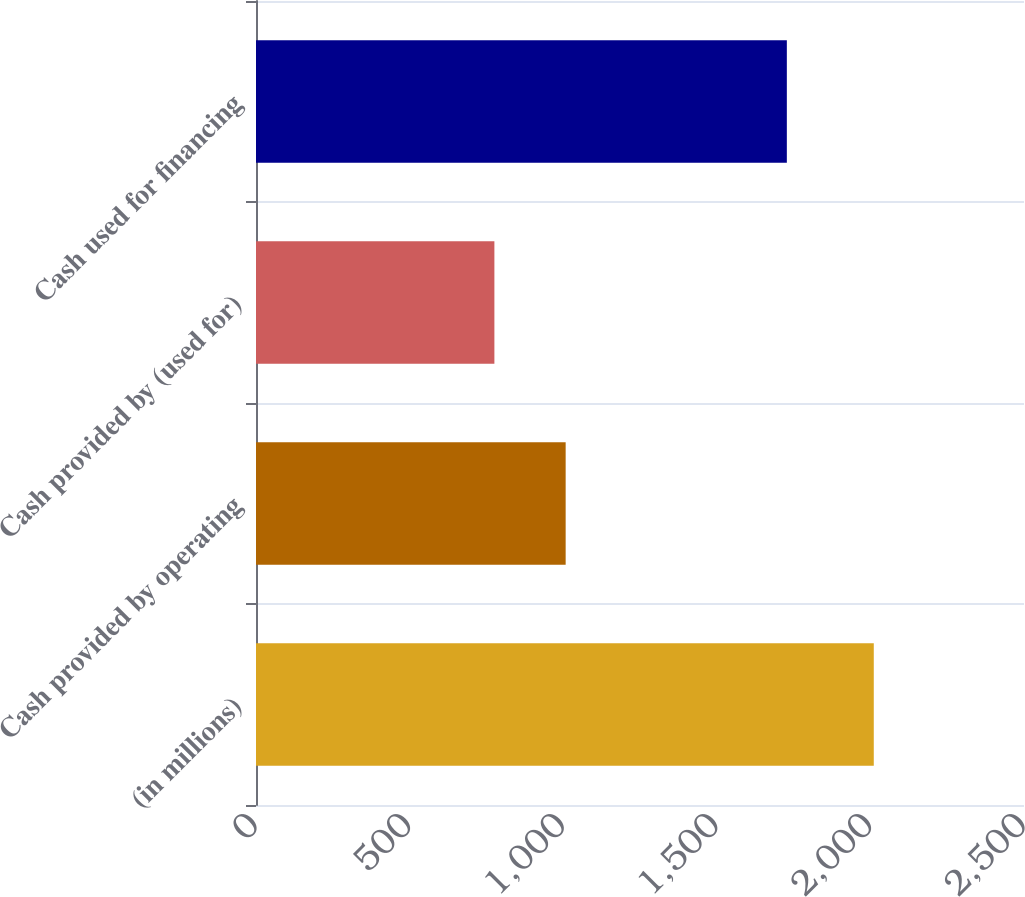<chart> <loc_0><loc_0><loc_500><loc_500><bar_chart><fcel>(in millions)<fcel>Cash provided by operating<fcel>Cash provided by (used for)<fcel>Cash used for financing<nl><fcel>2011<fcel>1008<fcel>776<fcel>1728<nl></chart> 